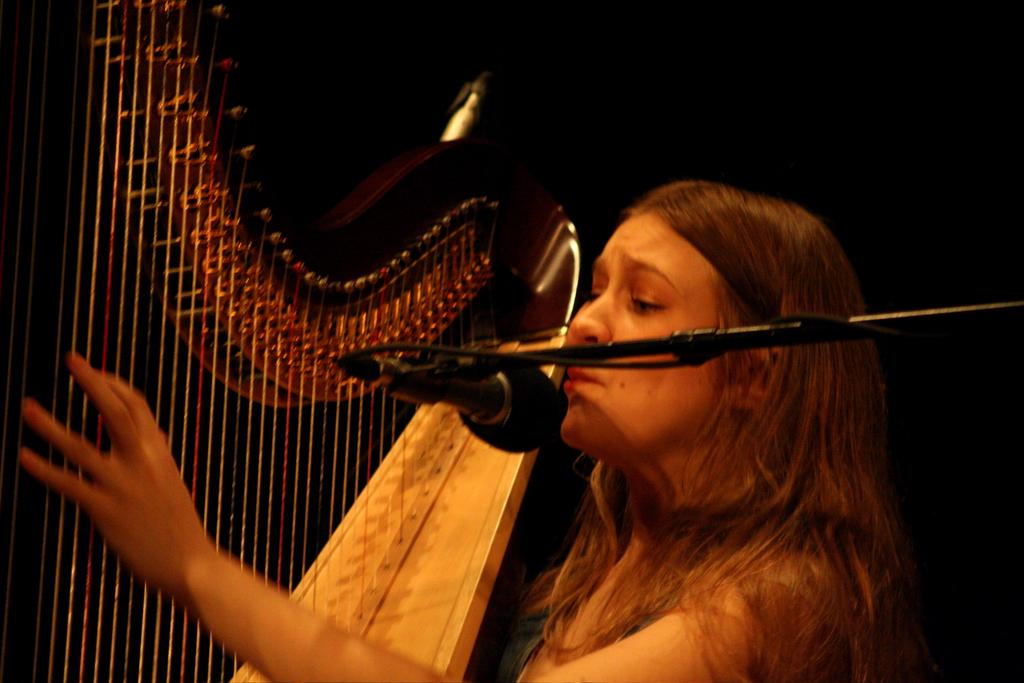Who is the main subject in the image? There is a woman in the image. What is the woman doing in the image? The woman is singing into a microphone and playing a musical instrument with her hand. How is the microphone positioned in the image? The microphone is on a stand. What type of berry is the woman holding in her hand while singing? There is no berry present in the image; the woman is playing a musical instrument with her hand. What language is the woman singing in the image? The image does not provide information about the language the woman is singing in. 